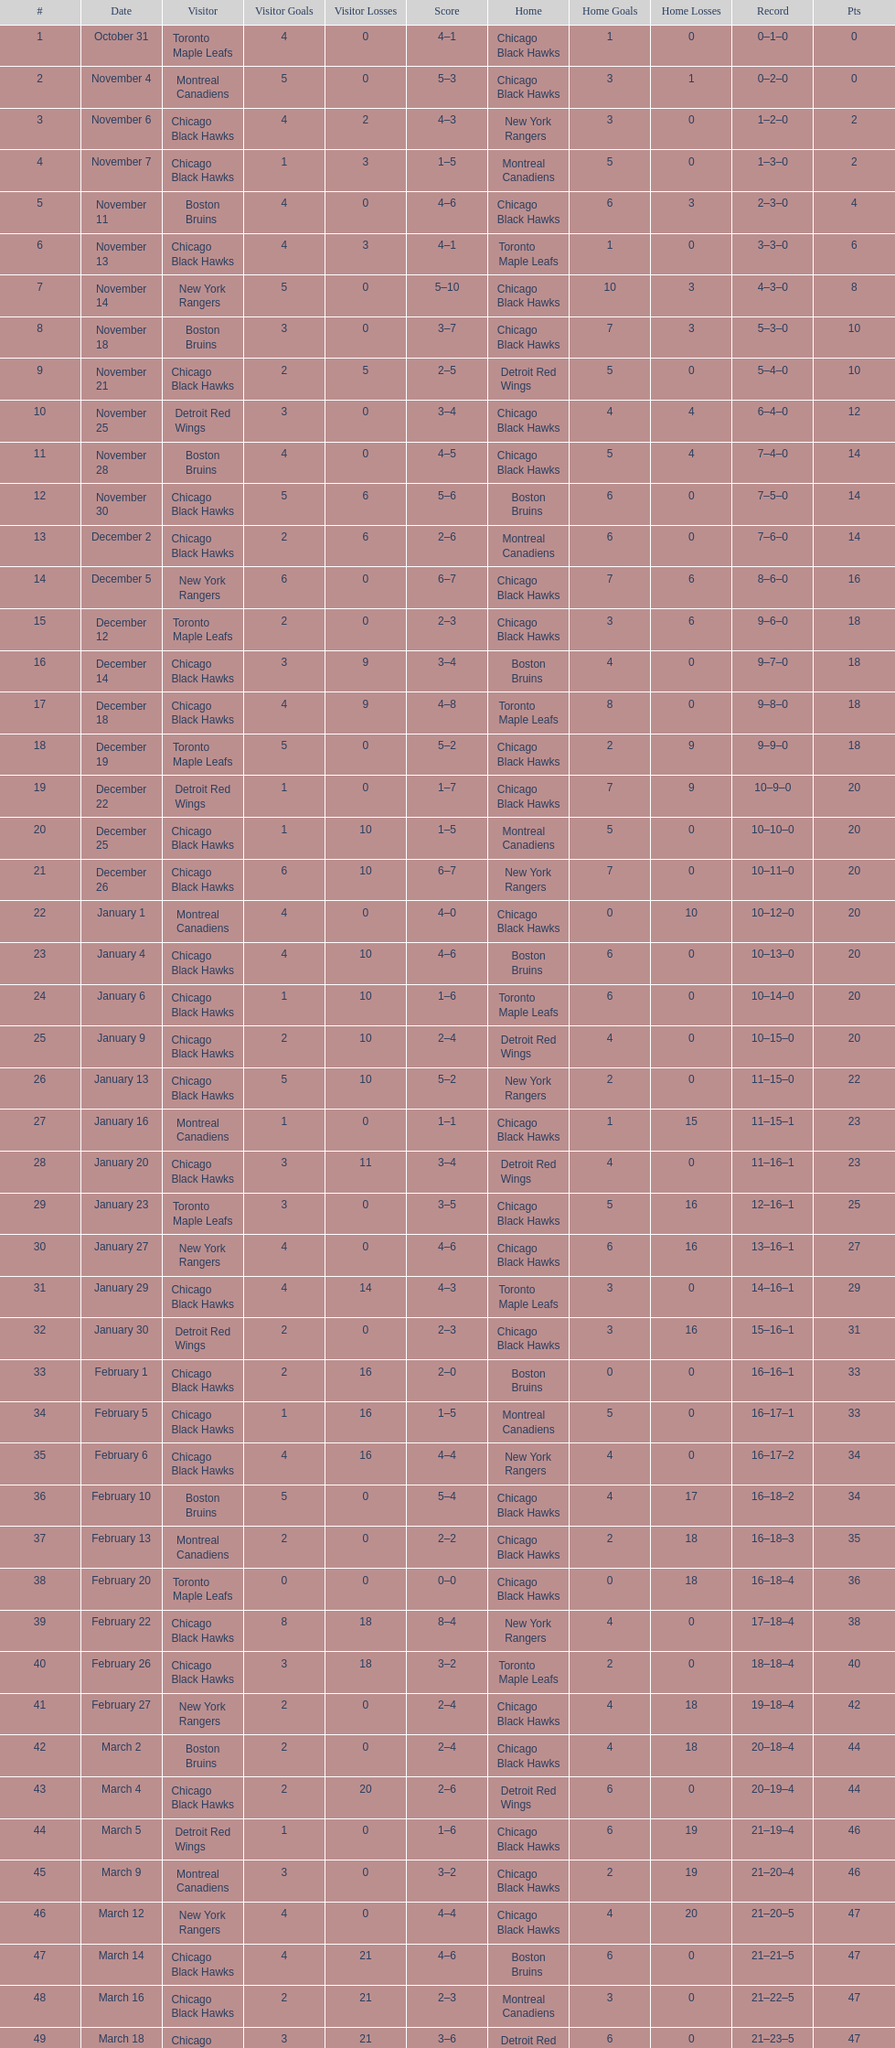Tell me the number of points the blackhawks had on march 4. 44. Write the full table. {'header': ['#', 'Date', 'Visitor', 'Visitor Goals', 'Visitor Losses', 'Score', 'Home', 'Home Goals', 'Home Losses', 'Record', 'Pts'], 'rows': [['1', 'October 31', 'Toronto Maple Leafs', '4', '0', '4–1', 'Chicago Black Hawks', '1', '0', '0–1–0', '0'], ['2', 'November 4', 'Montreal Canadiens', '5', '0', '5–3', 'Chicago Black Hawks', '3', '1', '0–2–0', '0'], ['3', 'November 6', 'Chicago Black Hawks', '4', '2', '4–3', 'New York Rangers', '3', '0', '1–2–0', '2'], ['4', 'November 7', 'Chicago Black Hawks', '1', '3', '1–5', 'Montreal Canadiens', '5', '0', '1–3–0', '2'], ['5', 'November 11', 'Boston Bruins', '4', '0', '4–6', 'Chicago Black Hawks', '6', '3', '2–3–0', '4'], ['6', 'November 13', 'Chicago Black Hawks', '4', '3', '4–1', 'Toronto Maple Leafs', '1', '0', '3–3–0', '6'], ['7', 'November 14', 'New York Rangers', '5', '0', '5–10', 'Chicago Black Hawks', '10', '3', '4–3–0', '8'], ['8', 'November 18', 'Boston Bruins', '3', '0', '3–7', 'Chicago Black Hawks', '7', '3', '5–3–0', '10'], ['9', 'November 21', 'Chicago Black Hawks', '2', '5', '2–5', 'Detroit Red Wings', '5', '0', '5–4–0', '10'], ['10', 'November 25', 'Detroit Red Wings', '3', '0', '3–4', 'Chicago Black Hawks', '4', '4', '6–4–0', '12'], ['11', 'November 28', 'Boston Bruins', '4', '0', '4–5', 'Chicago Black Hawks', '5', '4', '7–4–0', '14'], ['12', 'November 30', 'Chicago Black Hawks', '5', '6', '5–6', 'Boston Bruins', '6', '0', '7–5–0', '14'], ['13', 'December 2', 'Chicago Black Hawks', '2', '6', '2–6', 'Montreal Canadiens', '6', '0', '7–6–0', '14'], ['14', 'December 5', 'New York Rangers', '6', '0', '6–7', 'Chicago Black Hawks', '7', '6', '8–6–0', '16'], ['15', 'December 12', 'Toronto Maple Leafs', '2', '0', '2–3', 'Chicago Black Hawks', '3', '6', '9–6–0', '18'], ['16', 'December 14', 'Chicago Black Hawks', '3', '9', '3–4', 'Boston Bruins', '4', '0', '9–7–0', '18'], ['17', 'December 18', 'Chicago Black Hawks', '4', '9', '4–8', 'Toronto Maple Leafs', '8', '0', '9–8–0', '18'], ['18', 'December 19', 'Toronto Maple Leafs', '5', '0', '5–2', 'Chicago Black Hawks', '2', '9', '9–9–0', '18'], ['19', 'December 22', 'Detroit Red Wings', '1', '0', '1–7', 'Chicago Black Hawks', '7', '9', '10–9–0', '20'], ['20', 'December 25', 'Chicago Black Hawks', '1', '10', '1–5', 'Montreal Canadiens', '5', '0', '10–10–0', '20'], ['21', 'December 26', 'Chicago Black Hawks', '6', '10', '6–7', 'New York Rangers', '7', '0', '10–11–0', '20'], ['22', 'January 1', 'Montreal Canadiens', '4', '0', '4–0', 'Chicago Black Hawks', '0', '10', '10–12–0', '20'], ['23', 'January 4', 'Chicago Black Hawks', '4', '10', '4–6', 'Boston Bruins', '6', '0', '10–13–0', '20'], ['24', 'January 6', 'Chicago Black Hawks', '1', '10', '1–6', 'Toronto Maple Leafs', '6', '0', '10–14–0', '20'], ['25', 'January 9', 'Chicago Black Hawks', '2', '10', '2–4', 'Detroit Red Wings', '4', '0', '10–15–0', '20'], ['26', 'January 13', 'Chicago Black Hawks', '5', '10', '5–2', 'New York Rangers', '2', '0', '11–15–0', '22'], ['27', 'January 16', 'Montreal Canadiens', '1', '0', '1–1', 'Chicago Black Hawks', '1', '15', '11–15–1', '23'], ['28', 'January 20', 'Chicago Black Hawks', '3', '11', '3–4', 'Detroit Red Wings', '4', '0', '11–16–1', '23'], ['29', 'January 23', 'Toronto Maple Leafs', '3', '0', '3–5', 'Chicago Black Hawks', '5', '16', '12–16–1', '25'], ['30', 'January 27', 'New York Rangers', '4', '0', '4–6', 'Chicago Black Hawks', '6', '16', '13–16–1', '27'], ['31', 'January 29', 'Chicago Black Hawks', '4', '14', '4–3', 'Toronto Maple Leafs', '3', '0', '14–16–1', '29'], ['32', 'January 30', 'Detroit Red Wings', '2', '0', '2–3', 'Chicago Black Hawks', '3', '16', '15–16–1', '31'], ['33', 'February 1', 'Chicago Black Hawks', '2', '16', '2–0', 'Boston Bruins', '0', '0', '16–16–1', '33'], ['34', 'February 5', 'Chicago Black Hawks', '1', '16', '1–5', 'Montreal Canadiens', '5', '0', '16–17–1', '33'], ['35', 'February 6', 'Chicago Black Hawks', '4', '16', '4–4', 'New York Rangers', '4', '0', '16–17–2', '34'], ['36', 'February 10', 'Boston Bruins', '5', '0', '5–4', 'Chicago Black Hawks', '4', '17', '16–18–2', '34'], ['37', 'February 13', 'Montreal Canadiens', '2', '0', '2–2', 'Chicago Black Hawks', '2', '18', '16–18–3', '35'], ['38', 'February 20', 'Toronto Maple Leafs', '0', '0', '0–0', 'Chicago Black Hawks', '0', '18', '16–18–4', '36'], ['39', 'February 22', 'Chicago Black Hawks', '8', '18', '8–4', 'New York Rangers', '4', '0', '17–18–4', '38'], ['40', 'February 26', 'Chicago Black Hawks', '3', '18', '3–2', 'Toronto Maple Leafs', '2', '0', '18–18–4', '40'], ['41', 'February 27', 'New York Rangers', '2', '0', '2–4', 'Chicago Black Hawks', '4', '18', '19–18–4', '42'], ['42', 'March 2', 'Boston Bruins', '2', '0', '2–4', 'Chicago Black Hawks', '4', '18', '20–18–4', '44'], ['43', 'March 4', 'Chicago Black Hawks', '2', '20', '2–6', 'Detroit Red Wings', '6', '0', '20–19–4', '44'], ['44', 'March 5', 'Detroit Red Wings', '1', '0', '1–6', 'Chicago Black Hawks', '6', '19', '21–19–4', '46'], ['45', 'March 9', 'Montreal Canadiens', '3', '0', '3–2', 'Chicago Black Hawks', '2', '19', '21–20–4', '46'], ['46', 'March 12', 'New York Rangers', '4', '0', '4–4', 'Chicago Black Hawks', '4', '20', '21–20–5', '47'], ['47', 'March 14', 'Chicago Black Hawks', '4', '21', '4–6', 'Boston Bruins', '6', '0', '21–21–5', '47'], ['48', 'March 16', 'Chicago Black Hawks', '2', '21', '2–3', 'Montreal Canadiens', '3', '0', '21–22–5', '47'], ['49', 'March 18', 'Chicago Black Hawks', '3', '21', '3–6', 'Detroit Red Wings', '6', '0', '21–23–5', '47'], ['50', 'March 19', 'Detroit Red Wings', '0', '0', '0–2', 'Chicago Black Hawks', '2', '23', '22–23–5', '49']]} 